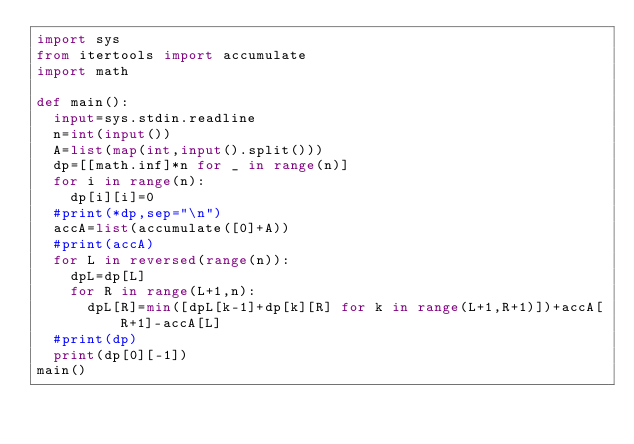Convert code to text. <code><loc_0><loc_0><loc_500><loc_500><_Python_>import sys
from itertools import accumulate
import math

def main():
  input=sys.stdin.readline
  n=int(input())
  A=list(map(int,input().split()))
  dp=[[math.inf]*n for _ in range(n)]
  for i in range(n):
    dp[i][i]=0
  #print(*dp,sep="\n")
  accA=list(accumulate([0]+A))
  #print(accA)
  for L in reversed(range(n)):
    dpL=dp[L]
    for R in range(L+1,n):
      dpL[R]=min([dpL[k-1]+dp[k][R] for k in range(L+1,R+1)])+accA[R+1]-accA[L]
  #print(dp)
  print(dp[0][-1])
main()</code> 